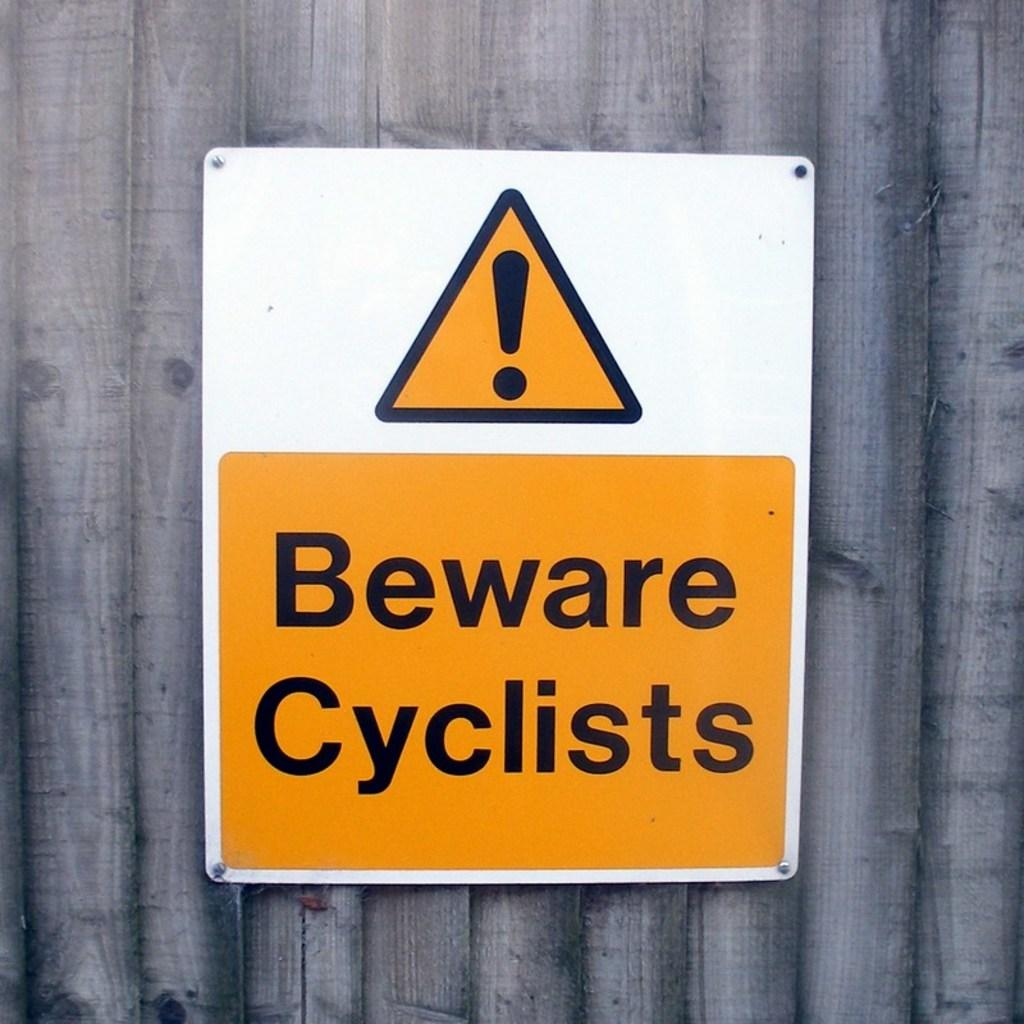Provide a one-sentence caption for the provided image. Big orange, black, and white sign that says beware cyclists. 